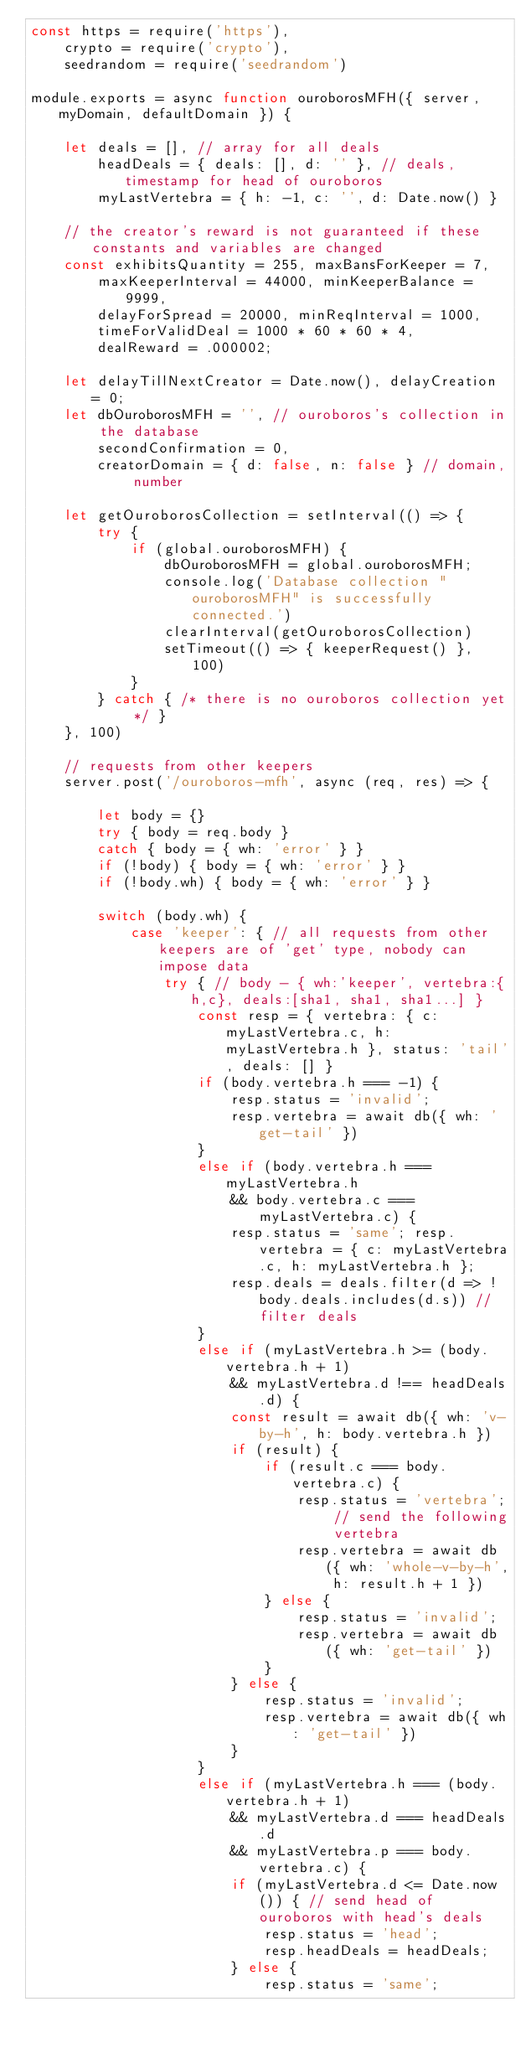<code> <loc_0><loc_0><loc_500><loc_500><_JavaScript_>const https = require('https'),
    crypto = require('crypto'),
    seedrandom = require('seedrandom')

module.exports = async function ouroborosMFH({ server, myDomain, defaultDomain }) {

    let deals = [], // array for all deals
        headDeals = { deals: [], d: '' }, // deals, timestamp for head of ouroboros
        myLastVertebra = { h: -1, c: '', d: Date.now() }

    // the creator's reward is not guaranteed if these constants and variables are changed
    const exhibitsQuantity = 255, maxBansForKeeper = 7,
        maxKeeperInterval = 44000, minKeeperBalance = 9999,
        delayForSpread = 20000, minReqInterval = 1000,
        timeForValidDeal = 1000 * 60 * 60 * 4,
        dealReward = .000002;

    let delayTillNextCreator = Date.now(), delayCreation = 0;
    let dbOuroborosMFH = '', // ouroboros's collection in the database
        secondConfirmation = 0,
        creatorDomain = { d: false, n: false } // domain, number

    let getOuroborosCollection = setInterval(() => {
        try {
            if (global.ouroborosMFH) {
                dbOuroborosMFH = global.ouroborosMFH;
                console.log('Database collection "ouroborosMFH" is successfully connected.')
                clearInterval(getOuroborosCollection)
                setTimeout(() => { keeperRequest() }, 100)
            }
        } catch { /* there is no ouroboros collection yet */ }
    }, 100)

    // requests from other keepers
    server.post('/ouroboros-mfh', async (req, res) => {

        let body = {}
        try { body = req.body }
        catch { body = { wh: 'error' } }
        if (!body) { body = { wh: 'error' } }
        if (!body.wh) { body = { wh: 'error' } }

        switch (body.wh) {
            case 'keeper': { // all requests from other keepers are of 'get' type, nobody can impose data
                try { // body - { wh:'keeper', vertebra:{h,c}, deals:[sha1, sha1, sha1...] }
                    const resp = { vertebra: { c: myLastVertebra.c, h: myLastVertebra.h }, status: 'tail', deals: [] }
                    if (body.vertebra.h === -1) {
                        resp.status = 'invalid';
                        resp.vertebra = await db({ wh: 'get-tail' })
                    }
                    else if (body.vertebra.h === myLastVertebra.h
                        && body.vertebra.c === myLastVertebra.c) {
                        resp.status = 'same'; resp.vertebra = { c: myLastVertebra.c, h: myLastVertebra.h };
                        resp.deals = deals.filter(d => !body.deals.includes(d.s)) // filter deals
                    }
                    else if (myLastVertebra.h >= (body.vertebra.h + 1)
                        && myLastVertebra.d !== headDeals.d) {
                        const result = await db({ wh: 'v-by-h', h: body.vertebra.h })
                        if (result) {
                            if (result.c === body.vertebra.c) {
                                resp.status = 'vertebra'; // send the following vertebra
                                resp.vertebra = await db({ wh: 'whole-v-by-h', h: result.h + 1 })
                            } else {
                                resp.status = 'invalid';
                                resp.vertebra = await db({ wh: 'get-tail' })
                            }
                        } else {
                            resp.status = 'invalid';
                            resp.vertebra = await db({ wh: 'get-tail' })
                        }
                    }
                    else if (myLastVertebra.h === (body.vertebra.h + 1)
                        && myLastVertebra.d === headDeals.d
                        && myLastVertebra.p === body.vertebra.c) {
                        if (myLastVertebra.d <= Date.now()) { // send head of ouroboros with head's deals
                            resp.status = 'head';
                            resp.headDeals = headDeals;
                        } else {
                            resp.status = 'same';</code> 